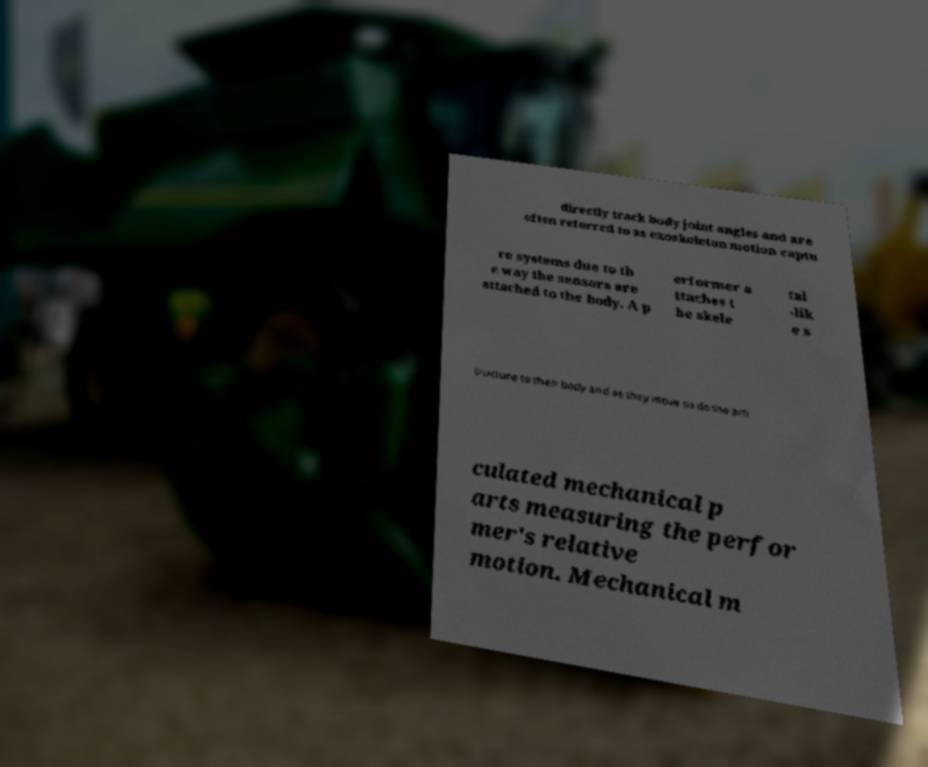Could you extract and type out the text from this image? directly track body joint angles and are often referred to as exoskeleton motion captu re systems due to th e way the sensors are attached to the body. A p erformer a ttaches t he skele tal -lik e s tructure to their body and as they move so do the arti culated mechanical p arts measuring the perfor mer's relative motion. Mechanical m 